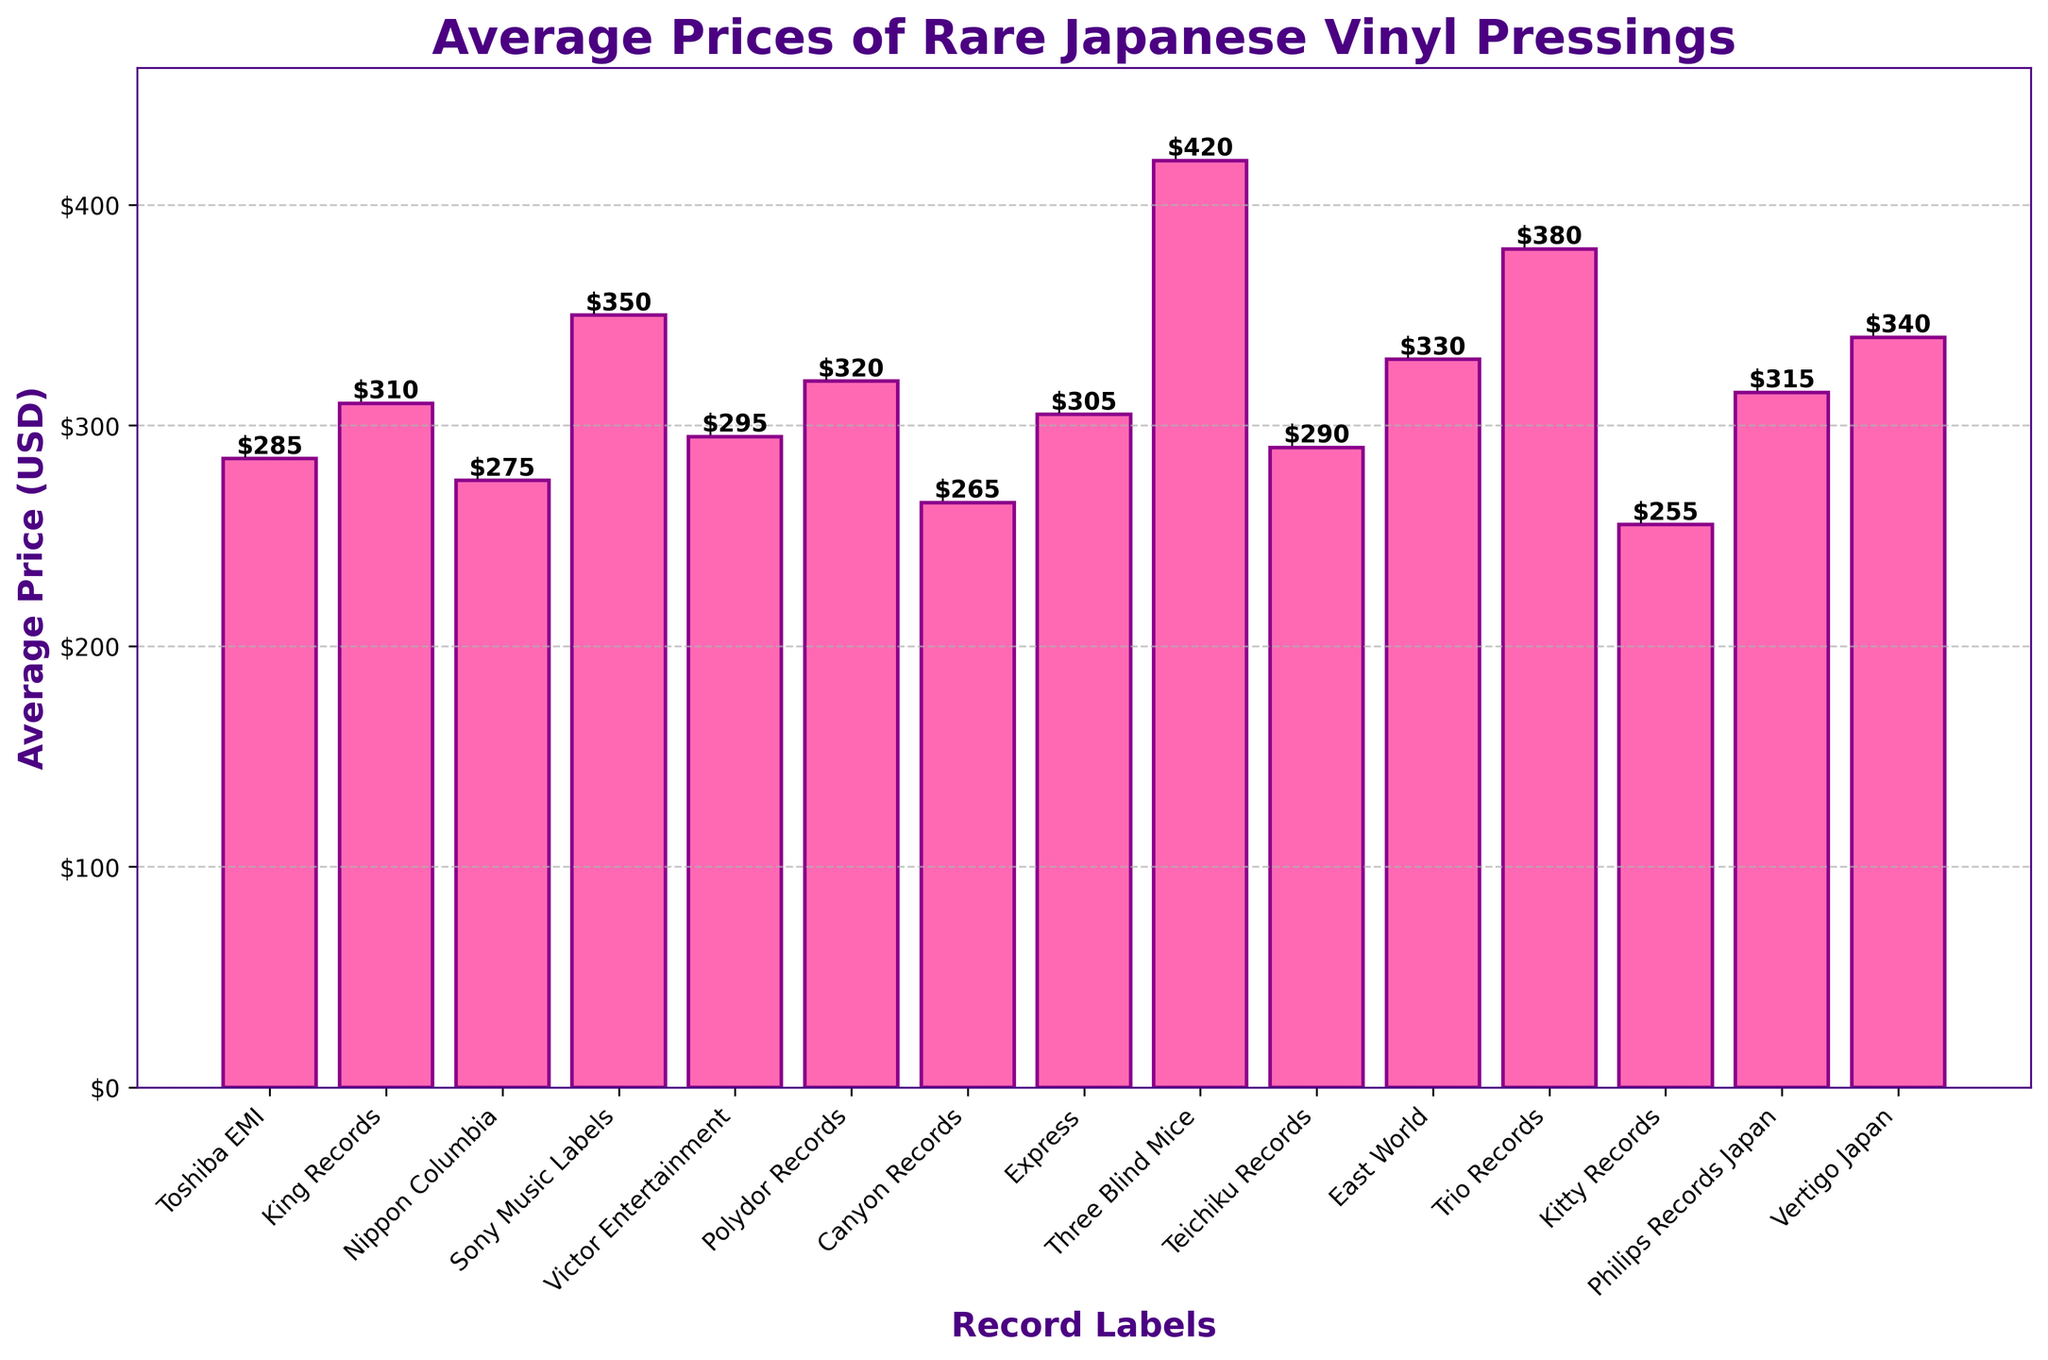Which label has the highest average price for rare Japanese vinyl pressings? By examining the heights of the bars, Three Blind Mice has the tallest bar, indicating it has the highest average price.
Answer: Three Blind Mice Which label has the lowest average price for rare Japanese vinyl pressings? By observing the heights of the bars, Kitty Records has the shortest bar, indicating it has the lowest average price.
Answer: Kitty Records What is the average price difference between Trio Records and Sony Music Labels? Trio Records has an average price of $380, and Sony Music Labels has an average price of $350. The difference is $380 - $350.
Answer: $30 What is the average price of vinyl pressings for labels with prices above $300? The labels with prices above $300 are Sony Music Labels ($350), Express ($305), Trio Records ($380), Philips Records Japan ($315), Vertigo Japan ($340), East World ($330), Polydor Records ($320). Sum these prices: $350 + $305 + $380 + $315 + $340 + $330 + $320 = $2340. There are 7 labels, so average = $2340 / 7.
Answer: $334.29 How much more expensive are records from Three Blind Mice compared to records from Canyon Records? Three Blind Mice has an average price of $420, and Canyon Records has an average price of $265. The difference is $420 - $265.
Answer: $155 Which labels have average prices within the range of $300 to $350? The prices within the $300 to $350 range are: Sony Music Labels ($350), Express ($305), Philips Records Japan ($315), Vertigo Japan ($340), East World ($330), and Polydor Records ($320).
Answer: Sony Music Labels, Express, Philips Records Japan, Vertigo Japan, East World, Polydor Records What is the combined average price of vinyl pressings for Victor Entertainment and Toshiba EMI? Victor Entertainment has an average price of $295, and Toshiba EMI has an average price of $285. Sum these prices: $295 + $285.
Answer: $580 Which label has an average price closest to $300? By examining the bars closest to $300, Express has an average price of $305, which is the closest to $300.
Answer: Express Calculate the total average price difference between the most expensive and the three least expensive labels. The most expensive is Three Blind Mice at $420. The three least expensive are Kitty Records ($255), Canyon Records ($265), and Nippon Columbia ($275). Sum of the least expensive: $255 + $265 + $275 = $795. The difference between the most expensive and the sum of the three least expensive: $420 - $795.
Answer: $-375 What is the average price for labels starting with the letter 'T'? The labels are Toshiba EMI ($285), Teichiku Records ($290), Trio Records ($380). Sum these prices: $285 + $290 + $380 = $955. There are 3 labels, so average = $955 / 3.
Answer: $318.33 